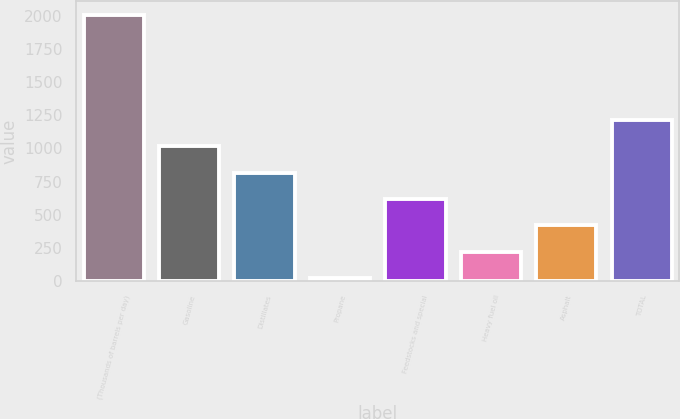Convert chart to OTSL. <chart><loc_0><loc_0><loc_500><loc_500><bar_chart><fcel>(Thousands of barrels per day)<fcel>Gasoline<fcel>Distillates<fcel>Propane<fcel>Feedstocks and special<fcel>Heavy fuel oil<fcel>Asphalt<fcel>TOTAL<nl><fcel>2008<fcel>1015<fcel>816.4<fcel>22<fcel>617.8<fcel>220.6<fcel>419.2<fcel>1213.6<nl></chart> 